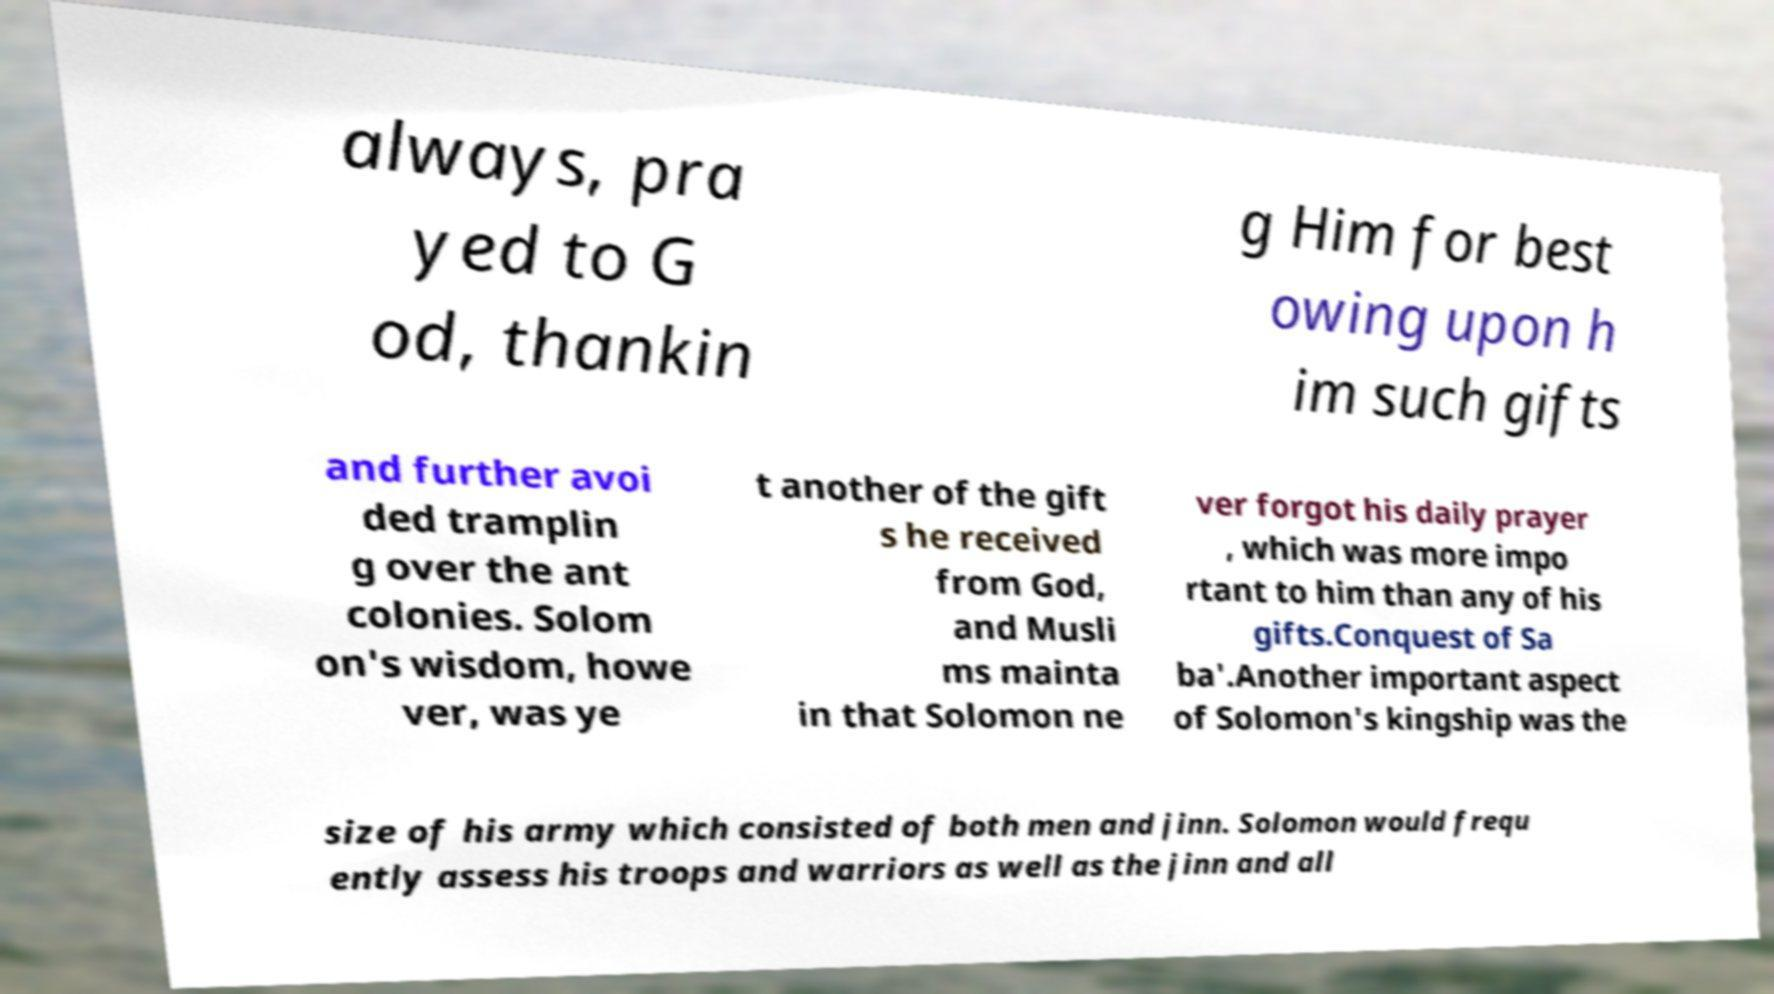Can you read and provide the text displayed in the image?This photo seems to have some interesting text. Can you extract and type it out for me? always, pra yed to G od, thankin g Him for best owing upon h im such gifts and further avoi ded tramplin g over the ant colonies. Solom on's wisdom, howe ver, was ye t another of the gift s he received from God, and Musli ms mainta in that Solomon ne ver forgot his daily prayer , which was more impo rtant to him than any of his gifts.Conquest of Sa ba'.Another important aspect of Solomon's kingship was the size of his army which consisted of both men and jinn. Solomon would frequ ently assess his troops and warriors as well as the jinn and all 